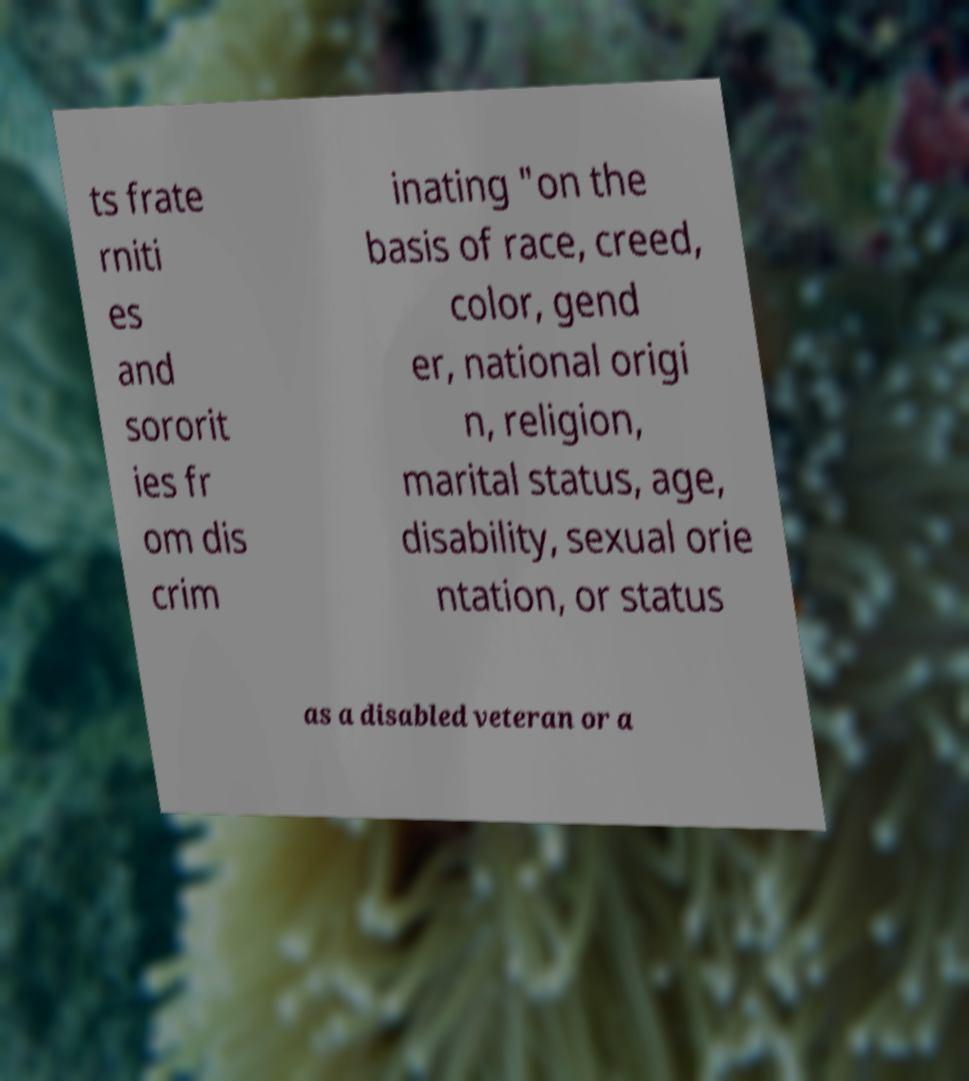There's text embedded in this image that I need extracted. Can you transcribe it verbatim? ts frate rniti es and sororit ies fr om dis crim inating "on the basis of race, creed, color, gend er, national origi n, religion, marital status, age, disability, sexual orie ntation, or status as a disabled veteran or a 